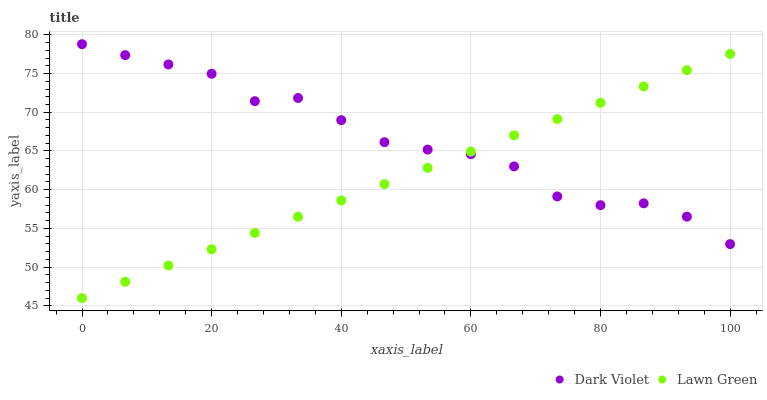Does Lawn Green have the minimum area under the curve?
Answer yes or no. Yes. Does Dark Violet have the maximum area under the curve?
Answer yes or no. Yes. Does Dark Violet have the minimum area under the curve?
Answer yes or no. No. Is Lawn Green the smoothest?
Answer yes or no. Yes. Is Dark Violet the roughest?
Answer yes or no. Yes. Is Dark Violet the smoothest?
Answer yes or no. No. Does Lawn Green have the lowest value?
Answer yes or no. Yes. Does Dark Violet have the lowest value?
Answer yes or no. No. Does Dark Violet have the highest value?
Answer yes or no. Yes. Does Lawn Green intersect Dark Violet?
Answer yes or no. Yes. Is Lawn Green less than Dark Violet?
Answer yes or no. No. Is Lawn Green greater than Dark Violet?
Answer yes or no. No. 